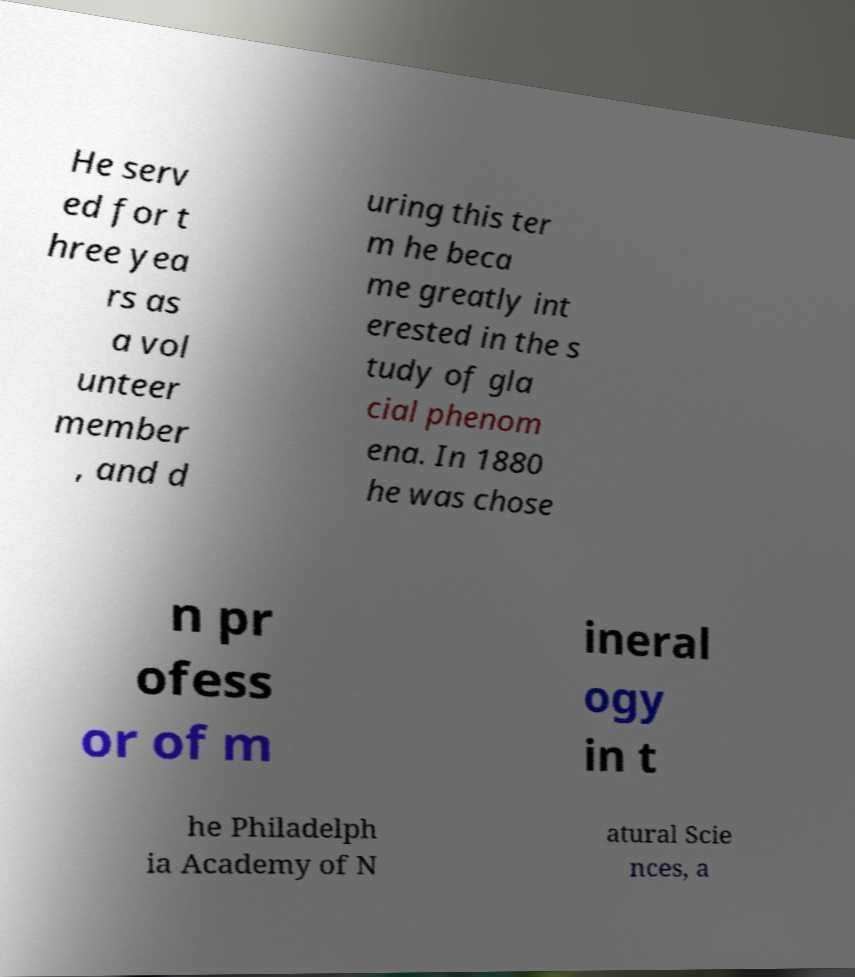What messages or text are displayed in this image? I need them in a readable, typed format. He serv ed for t hree yea rs as a vol unteer member , and d uring this ter m he beca me greatly int erested in the s tudy of gla cial phenom ena. In 1880 he was chose n pr ofess or of m ineral ogy in t he Philadelph ia Academy of N atural Scie nces, a 